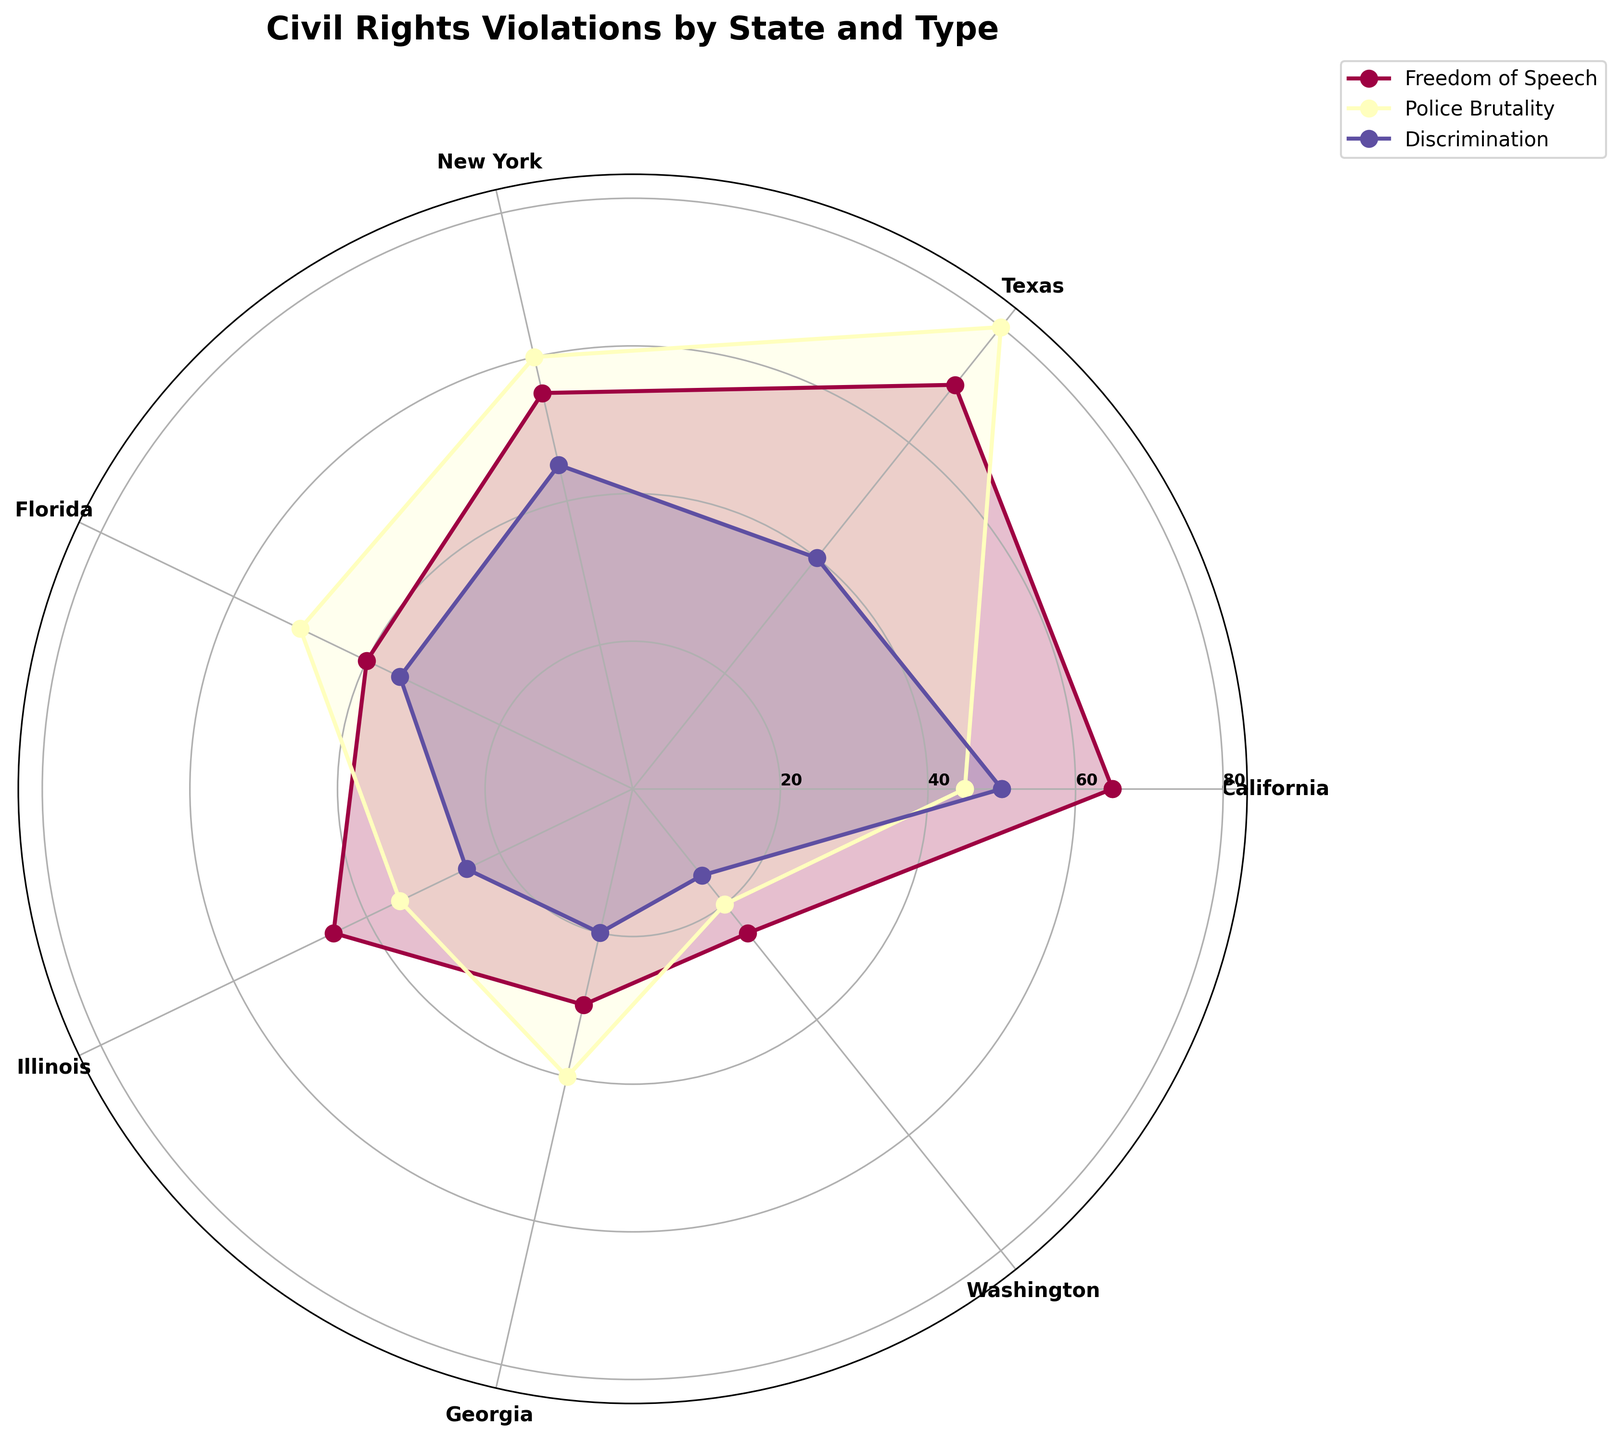What is the title of the figure? The title is located at the top of the figure. It provides a description of what the visual represents.
Answer: Civil Rights Violations by State and Type Which state has the highest reported instances of Police Brutality? By observing the length of the segment representing Police Brutality, Texas has the longest, indicating it has the highest reported instances.
Answer: Texas How many types of civil rights violations are reported in the figure? Counting the different categories listed in the legend, there are three types of violations represented.
Answer: Three What is the median frequency of Freedom of Speech violations across all states? To find the median, list the frequencies of Freedom of Speech violations (65, 70, 55, 40, 45, 30, 25), then arrange them in order (25, 30, 40, 45, 55, 65, 70). The median value is the middle one.
Answer: 45 Which state has the lowest overall instances of civil rights violations? Sum up the frequencies of all violation types for each state, then identify the state with the smallest total. Washington (25+20+15) has the lowest overall instances.
Answer: Washington How do the frequencies of Discrimination violations in California and New York compare? Observe the segments for Discrimination in both states. California has a segment of length 50, while New York has a segment of length 45.
Answer: California has higher Which type of violation is most frequently reported in Florida? By comparing the lengths of segments for all types in Florida, the longest segment corresponds to Police Brutality.
Answer: Police Brutality What is the average frequency of Police Brutality violations across all states? Sum the frequencies of Police Brutality violations (45+80+60+50+35+40+20), giving 330. Then divide by 7 states to get the average: 330/7.
Answer: 47.14 How does the frequency of Freedom of Speech violations in Georgia compare to Illinois? Compare the segments for Freedom of Speech violations; Georgia has 30, while Illinois has 45.
Answer: Illinois is higher Which state has the most equal distribution of reported civil rights violations across the three types? The state whose segments are most similar in length for all three types has the most equal distribution. California (65/45/50) appears to have the most balanced segments.
Answer: California 